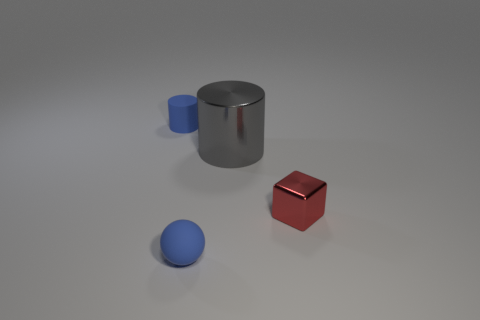How many objects have the same material as the blue cylinder? There appear to be two objects, a large grey cylinder and a small blue sphere, that share a similar shiny metallic material with the blue cylinder. 